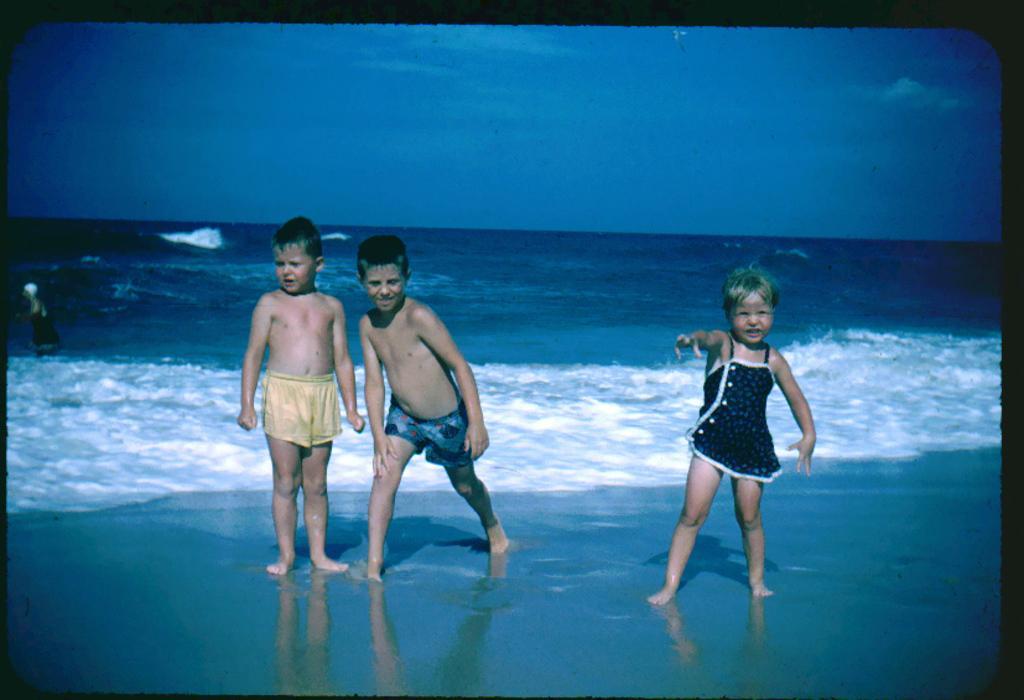Please provide a concise description of this image. In this image we can see few children on the sea shore and in the background we can see the sky. 